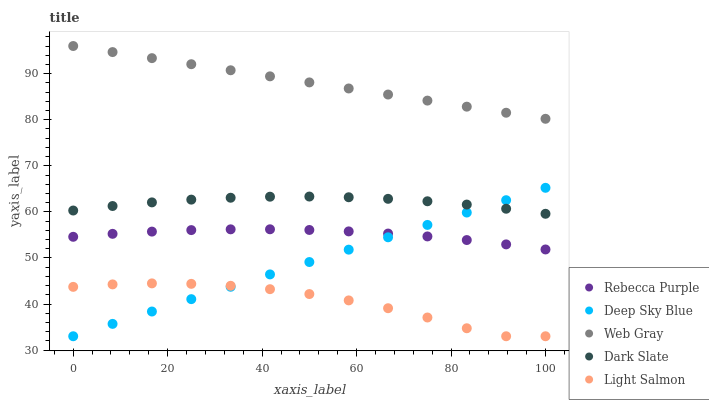Does Light Salmon have the minimum area under the curve?
Answer yes or no. Yes. Does Web Gray have the maximum area under the curve?
Answer yes or no. Yes. Does Web Gray have the minimum area under the curve?
Answer yes or no. No. Does Light Salmon have the maximum area under the curve?
Answer yes or no. No. Is Deep Sky Blue the smoothest?
Answer yes or no. Yes. Is Light Salmon the roughest?
Answer yes or no. Yes. Is Web Gray the smoothest?
Answer yes or no. No. Is Web Gray the roughest?
Answer yes or no. No. Does Light Salmon have the lowest value?
Answer yes or no. Yes. Does Web Gray have the lowest value?
Answer yes or no. No. Does Web Gray have the highest value?
Answer yes or no. Yes. Does Light Salmon have the highest value?
Answer yes or no. No. Is Light Salmon less than Dark Slate?
Answer yes or no. Yes. Is Web Gray greater than Light Salmon?
Answer yes or no. Yes. Does Deep Sky Blue intersect Light Salmon?
Answer yes or no. Yes. Is Deep Sky Blue less than Light Salmon?
Answer yes or no. No. Is Deep Sky Blue greater than Light Salmon?
Answer yes or no. No. Does Light Salmon intersect Dark Slate?
Answer yes or no. No. 